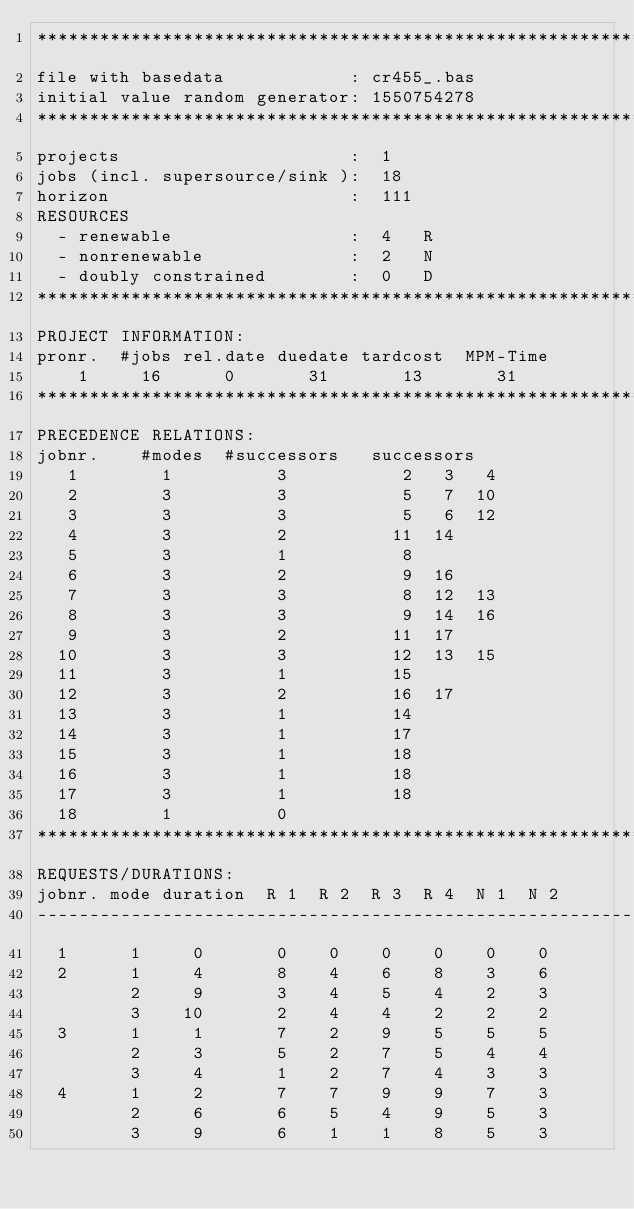<code> <loc_0><loc_0><loc_500><loc_500><_ObjectiveC_>************************************************************************
file with basedata            : cr455_.bas
initial value random generator: 1550754278
************************************************************************
projects                      :  1
jobs (incl. supersource/sink ):  18
horizon                       :  111
RESOURCES
  - renewable                 :  4   R
  - nonrenewable              :  2   N
  - doubly constrained        :  0   D
************************************************************************
PROJECT INFORMATION:
pronr.  #jobs rel.date duedate tardcost  MPM-Time
    1     16      0       31       13       31
************************************************************************
PRECEDENCE RELATIONS:
jobnr.    #modes  #successors   successors
   1        1          3           2   3   4
   2        3          3           5   7  10
   3        3          3           5   6  12
   4        3          2          11  14
   5        3          1           8
   6        3          2           9  16
   7        3          3           8  12  13
   8        3          3           9  14  16
   9        3          2          11  17
  10        3          3          12  13  15
  11        3          1          15
  12        3          2          16  17
  13        3          1          14
  14        3          1          17
  15        3          1          18
  16        3          1          18
  17        3          1          18
  18        1          0        
************************************************************************
REQUESTS/DURATIONS:
jobnr. mode duration  R 1  R 2  R 3  R 4  N 1  N 2
------------------------------------------------------------------------
  1      1     0       0    0    0    0    0    0
  2      1     4       8    4    6    8    3    6
         2     9       3    4    5    4    2    3
         3    10       2    4    4    2    2    2
  3      1     1       7    2    9    5    5    5
         2     3       5    2    7    5    4    4
         3     4       1    2    7    4    3    3
  4      1     2       7    7    9    9    7    3
         2     6       6    5    4    9    5    3
         3     9       6    1    1    8    5    3</code> 